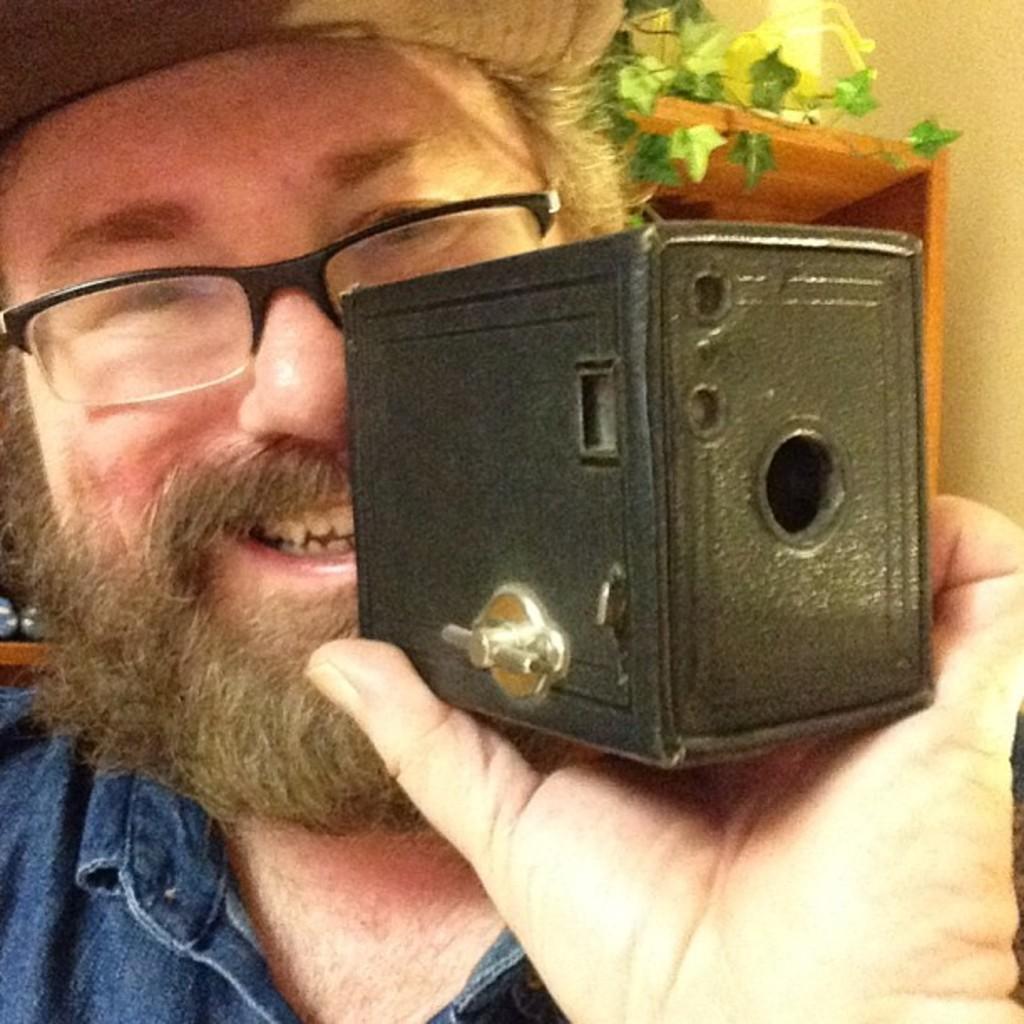Could you give a brief overview of what you see in this image? Here we can see a person holding something in his hand, laughing, wearing spectacles and cap and him we can see a plant 